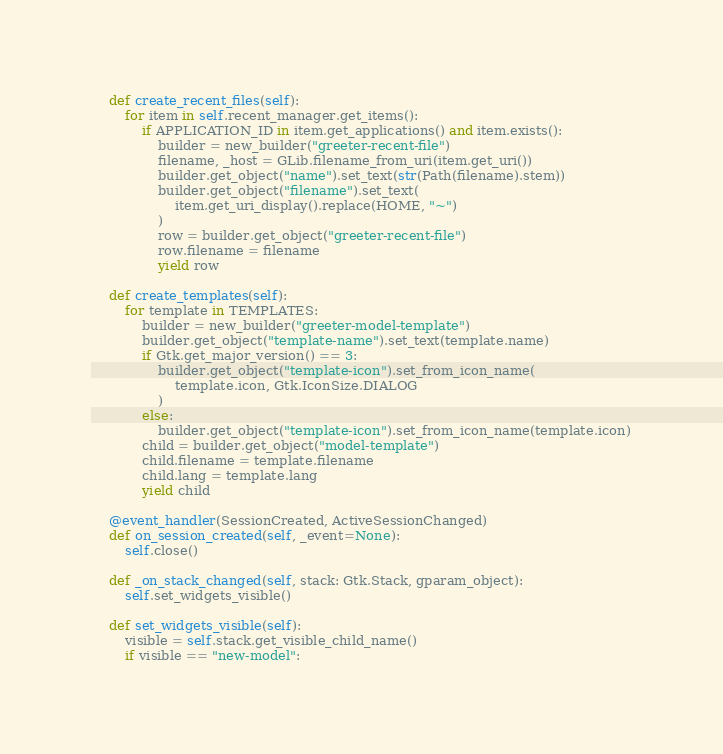<code> <loc_0><loc_0><loc_500><loc_500><_Python_>    def create_recent_files(self):
        for item in self.recent_manager.get_items():
            if APPLICATION_ID in item.get_applications() and item.exists():
                builder = new_builder("greeter-recent-file")
                filename, _host = GLib.filename_from_uri(item.get_uri())
                builder.get_object("name").set_text(str(Path(filename).stem))
                builder.get_object("filename").set_text(
                    item.get_uri_display().replace(HOME, "~")
                )
                row = builder.get_object("greeter-recent-file")
                row.filename = filename
                yield row

    def create_templates(self):
        for template in TEMPLATES:
            builder = new_builder("greeter-model-template")
            builder.get_object("template-name").set_text(template.name)
            if Gtk.get_major_version() == 3:
                builder.get_object("template-icon").set_from_icon_name(
                    template.icon, Gtk.IconSize.DIALOG
                )
            else:
                builder.get_object("template-icon").set_from_icon_name(template.icon)
            child = builder.get_object("model-template")
            child.filename = template.filename
            child.lang = template.lang
            yield child

    @event_handler(SessionCreated, ActiveSessionChanged)
    def on_session_created(self, _event=None):
        self.close()

    def _on_stack_changed(self, stack: Gtk.Stack, gparam_object):
        self.set_widgets_visible()

    def set_widgets_visible(self):
        visible = self.stack.get_visible_child_name()
        if visible == "new-model":</code> 